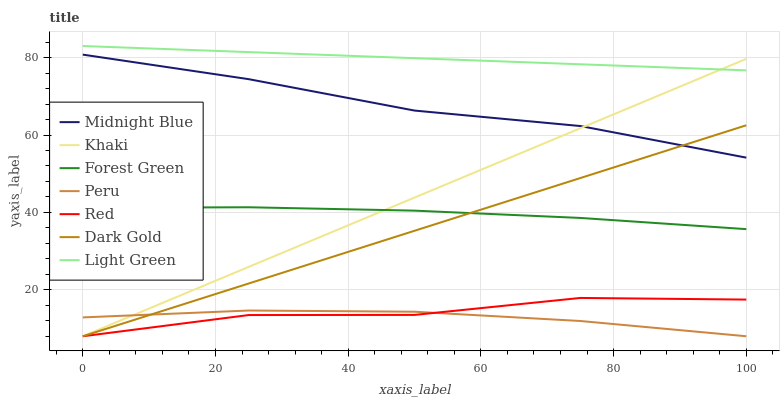Does Peru have the minimum area under the curve?
Answer yes or no. Yes. Does Light Green have the maximum area under the curve?
Answer yes or no. Yes. Does Midnight Blue have the minimum area under the curve?
Answer yes or no. No. Does Midnight Blue have the maximum area under the curve?
Answer yes or no. No. Is Light Green the smoothest?
Answer yes or no. Yes. Is Red the roughest?
Answer yes or no. Yes. Is Midnight Blue the smoothest?
Answer yes or no. No. Is Midnight Blue the roughest?
Answer yes or no. No. Does Khaki have the lowest value?
Answer yes or no. Yes. Does Midnight Blue have the lowest value?
Answer yes or no. No. Does Light Green have the highest value?
Answer yes or no. Yes. Does Midnight Blue have the highest value?
Answer yes or no. No. Is Dark Gold less than Light Green?
Answer yes or no. Yes. Is Light Green greater than Midnight Blue?
Answer yes or no. Yes. Does Dark Gold intersect Khaki?
Answer yes or no. Yes. Is Dark Gold less than Khaki?
Answer yes or no. No. Is Dark Gold greater than Khaki?
Answer yes or no. No. Does Dark Gold intersect Light Green?
Answer yes or no. No. 